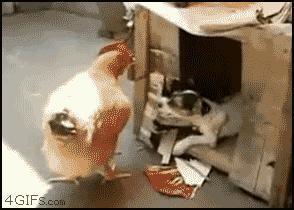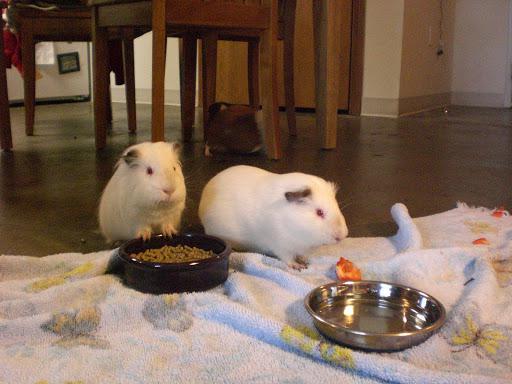The first image is the image on the left, the second image is the image on the right. Analyze the images presented: Is the assertion "The animal in one of the images is in a wire cage." valid? Answer yes or no. No. 